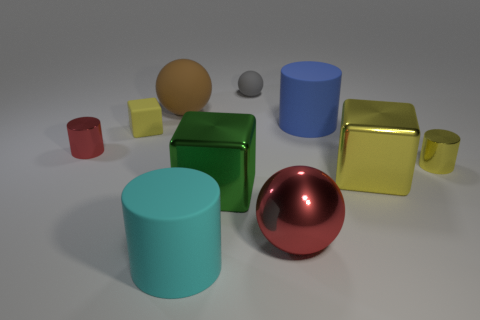Subtract 0 green spheres. How many objects are left? 10 Subtract all cubes. How many objects are left? 7 Subtract 1 spheres. How many spheres are left? 2 Subtract all gray cylinders. Subtract all cyan balls. How many cylinders are left? 4 Subtract all blue cubes. How many yellow cylinders are left? 1 Subtract all small purple metal objects. Subtract all red shiny cylinders. How many objects are left? 9 Add 2 yellow rubber objects. How many yellow rubber objects are left? 3 Add 2 small gray things. How many small gray things exist? 3 Subtract all blue cylinders. How many cylinders are left? 3 Subtract all small red cylinders. How many cylinders are left? 3 